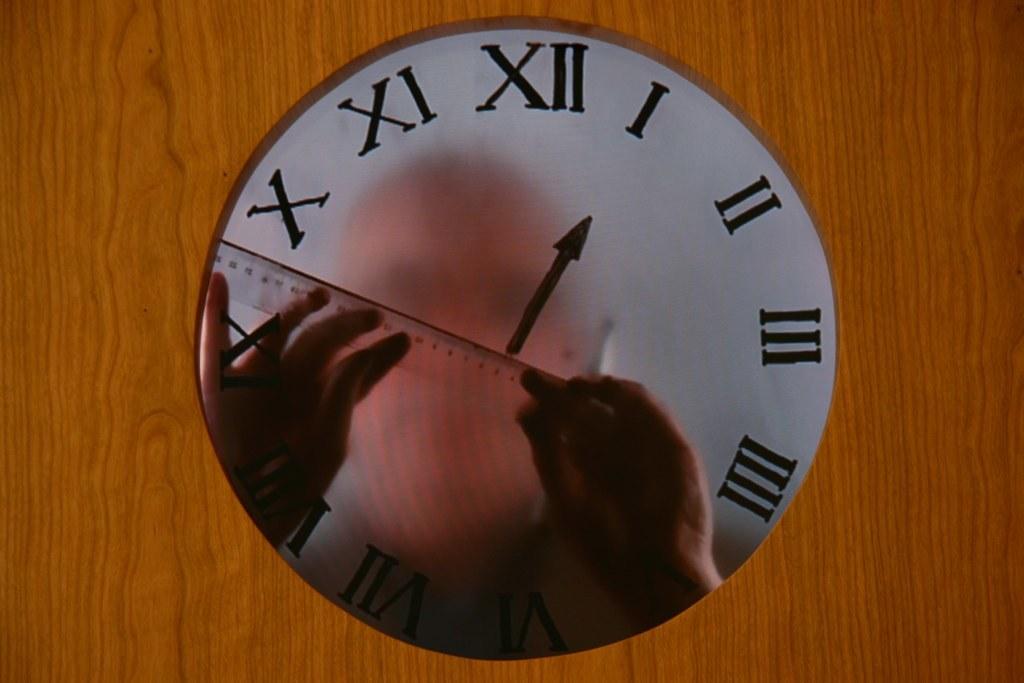Which numeral is the arrow pointing to?
Provide a short and direct response. 1. 